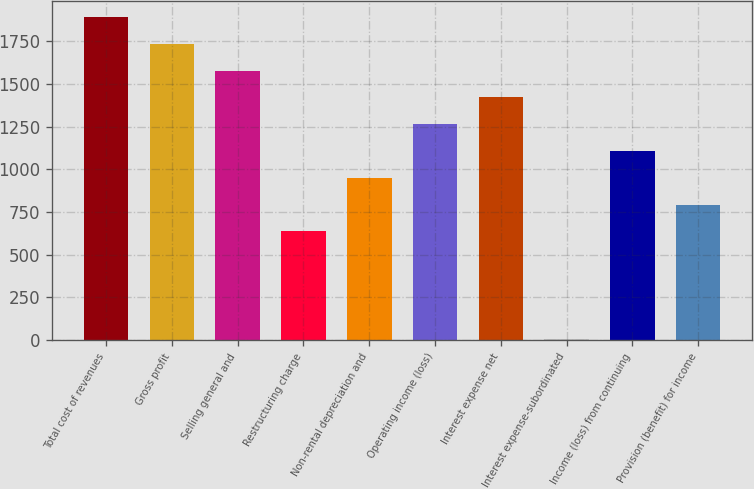Convert chart to OTSL. <chart><loc_0><loc_0><loc_500><loc_500><bar_chart><fcel>Total cost of revenues<fcel>Gross profit<fcel>Selling general and<fcel>Restructuring charge<fcel>Non-rental depreciation and<fcel>Operating income (loss)<fcel>Interest expense net<fcel>Interest expense-subordinated<fcel>Income (loss) from continuing<fcel>Provision (benefit) for income<nl><fcel>1893.2<fcel>1736.1<fcel>1579<fcel>636.4<fcel>950.6<fcel>1264.8<fcel>1421.9<fcel>8<fcel>1107.7<fcel>793.5<nl></chart> 